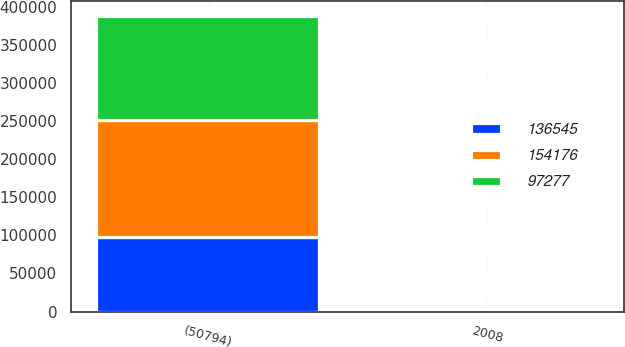<chart> <loc_0><loc_0><loc_500><loc_500><stacked_bar_chart><ecel><fcel>2008<fcel>(50794)<nl><fcel>154176<fcel>2007<fcel>154176<nl><fcel>136545<fcel>2006<fcel>97277<nl><fcel>97277<fcel>2005<fcel>136545<nl></chart> 